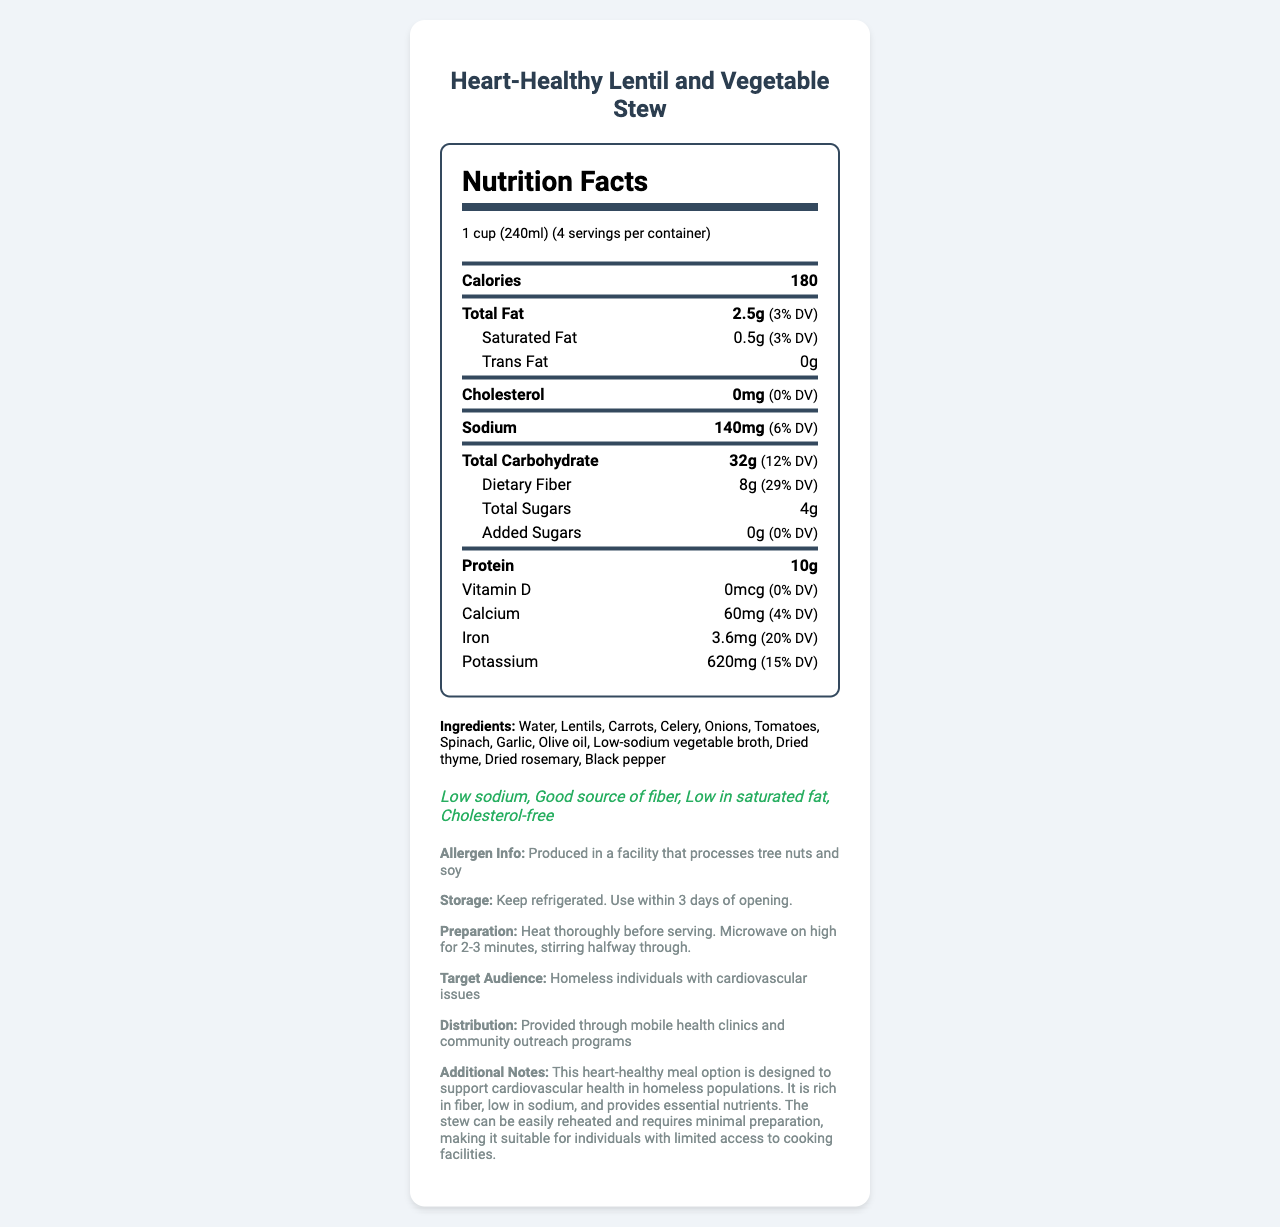who is the target audience for this product? The document explicitly states that the target audience is "homeless individuals with cardiovascular issues."
Answer: Homeless individuals with cardiovascular issues what is the serving size of the Heart-Healthy Lentil and Vegetable Stew? The serving size is mentioned as "1 cup (240ml)" in the document.
Answer: 1 cup (240ml) how much dietary fiber is in one serving? The nutrition label shows that there are 8 grams of dietary fiber in one serving.
Answer: 8g what percentage of the daily value of iron is provided by one serving? The document states that one serving offers 3.6mg of iron, which constitutes 20% of the daily value.
Answer: 20% how many calories are there in one cup of this stew? The nutrition label lists 180 calories per 1-cup serving.
Answer: 180 how many grams of protein are in one serving? The document specifies that one serving contains 10 grams of protein.
Answer: 10g what is the total carbohydrate content per serving? The total carbohydrate content per serving is given as 32 grams.
Answer: 32g does this product contain any cholesterol? The nutrition label states that there is 0mg of cholesterol in this product.
Answer: No what allergen information is provided? The allergen information specifies that the product is produced in a facility that processes tree nuts and soy.
Answer: Produced in a facility that processes tree nuts and soy which of the following health claims are associated with this product? A. High sodium B. Good source of fiber C. High in saturated fat D. Cholesterol-free The health claims listed are "Good source of fiber" and "Cholesterol-free."
Answer: B and D what are the preparation instructions for this product? The document provides these specific preparation instructions.
Answer: Heat thoroughly before serving. Microwave on high for 2-3 minutes, stirring halfway through. how many servings are there per container? The document states that there are 4 servings per container.
Answer: 4 how much sodium is in one serving, and what percentage of the daily value does this represent? The sodium content per serving is 140mg, which represents 6% of the daily value.
Answer: 140mg and 6% what is the main idea of this document? This summarizes the document, which includes nutrition details, ingredients, health claims, and additional product information targeted at a specific vulnerable population.
Answer: The document provides the nutrition facts, ingredients, health claims, allergen information, storage instructions, target audience, distribution method, and additional notes for a heart-healthy, low-sodium lentil and vegetable stew designed for homeless individuals with cardiovascular issues. is this product high in added sugars? The document indicates that the added sugars amount is 0g, which is 0% of the daily value.
Answer: No can the serving size be determined from this document? The serving size is clearly listed as 1 cup (240ml).
Answer: Yes what is the primary distribution method mentioned? The document specifies that the product is distributed through mobile health clinics and community outreach programs.
Answer: Provided through mobile health clinics and community outreach programs 